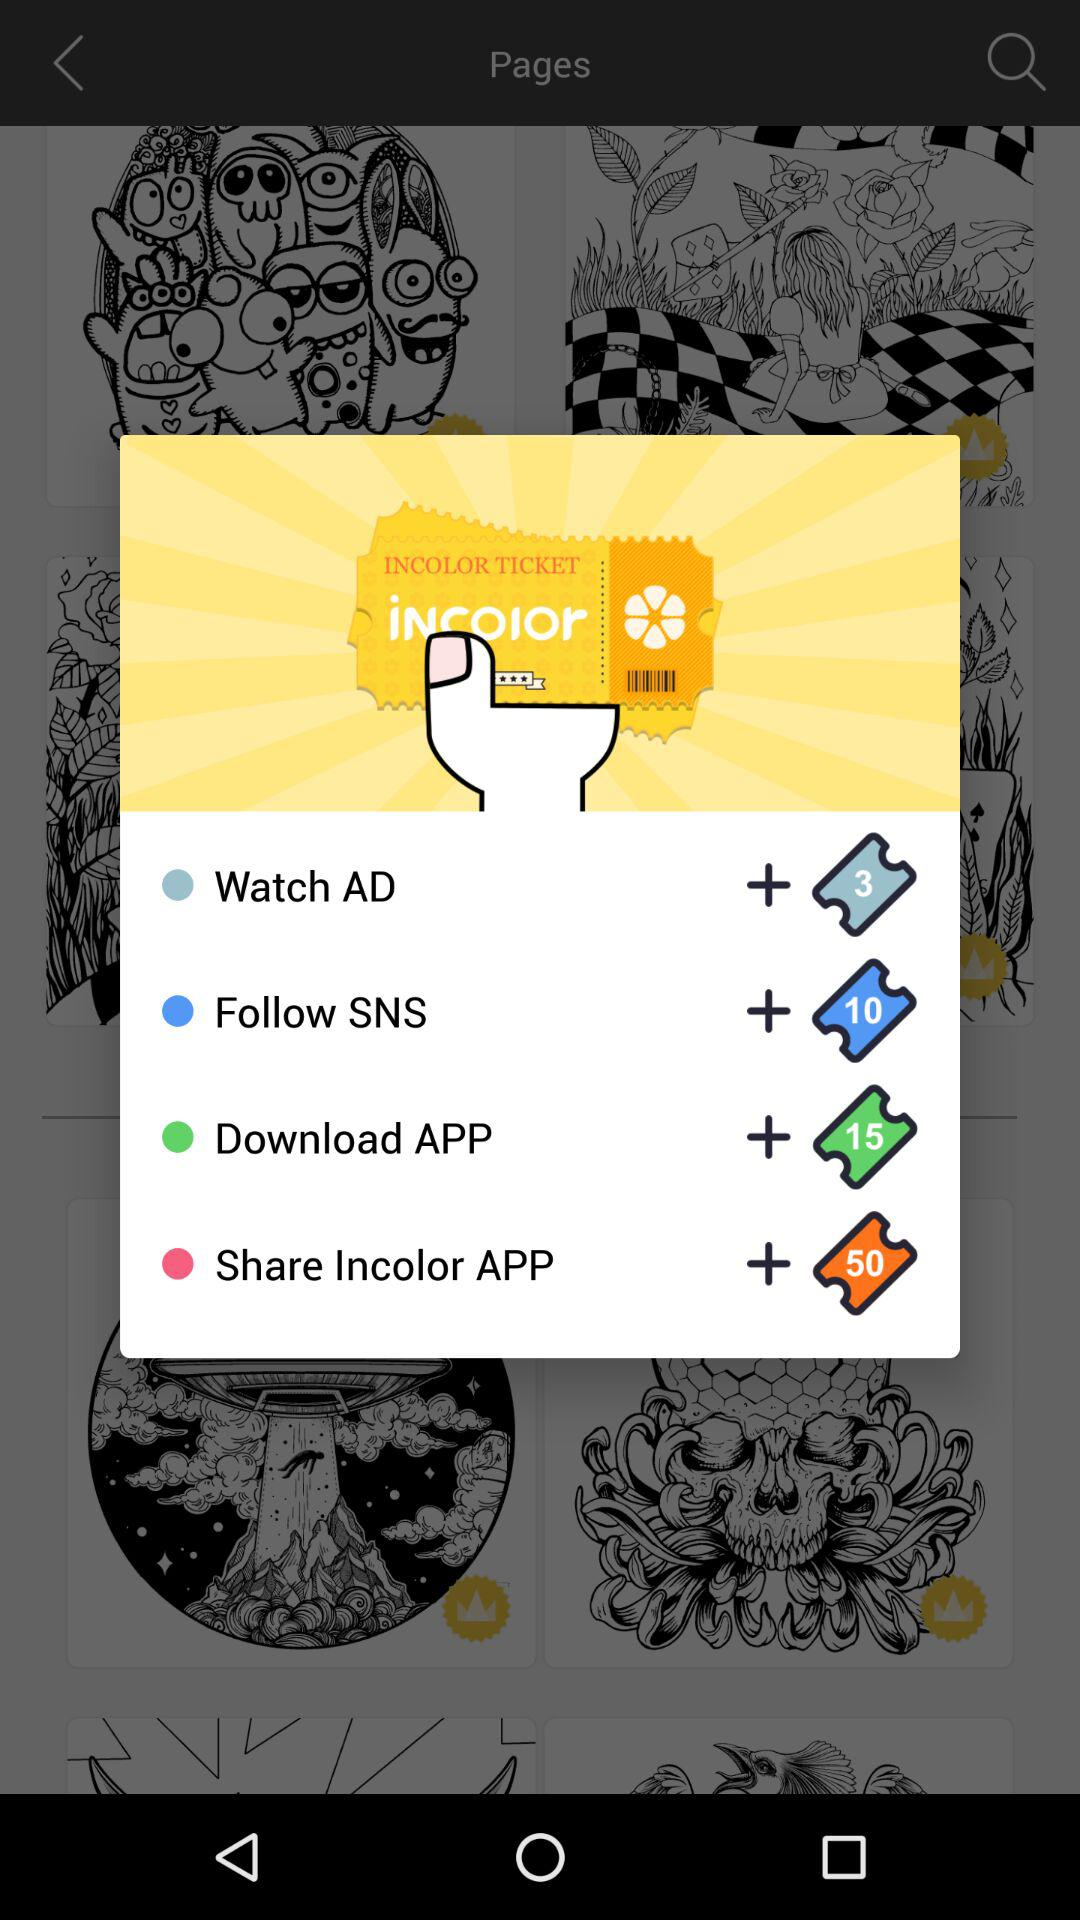How many points are needed to redeem the smallest reward?
Answer the question using a single word or phrase. 3 